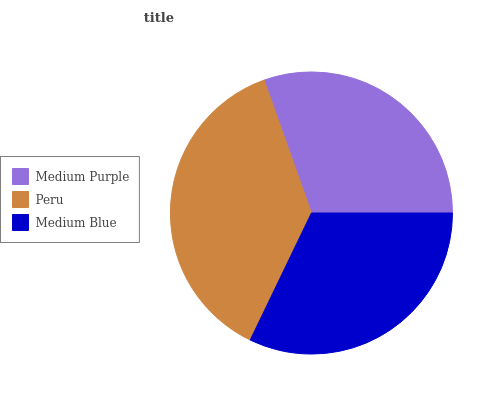Is Medium Purple the minimum?
Answer yes or no. Yes. Is Peru the maximum?
Answer yes or no. Yes. Is Medium Blue the minimum?
Answer yes or no. No. Is Medium Blue the maximum?
Answer yes or no. No. Is Peru greater than Medium Blue?
Answer yes or no. Yes. Is Medium Blue less than Peru?
Answer yes or no. Yes. Is Medium Blue greater than Peru?
Answer yes or no. No. Is Peru less than Medium Blue?
Answer yes or no. No. Is Medium Blue the high median?
Answer yes or no. Yes. Is Medium Blue the low median?
Answer yes or no. Yes. Is Medium Purple the high median?
Answer yes or no. No. Is Medium Purple the low median?
Answer yes or no. No. 